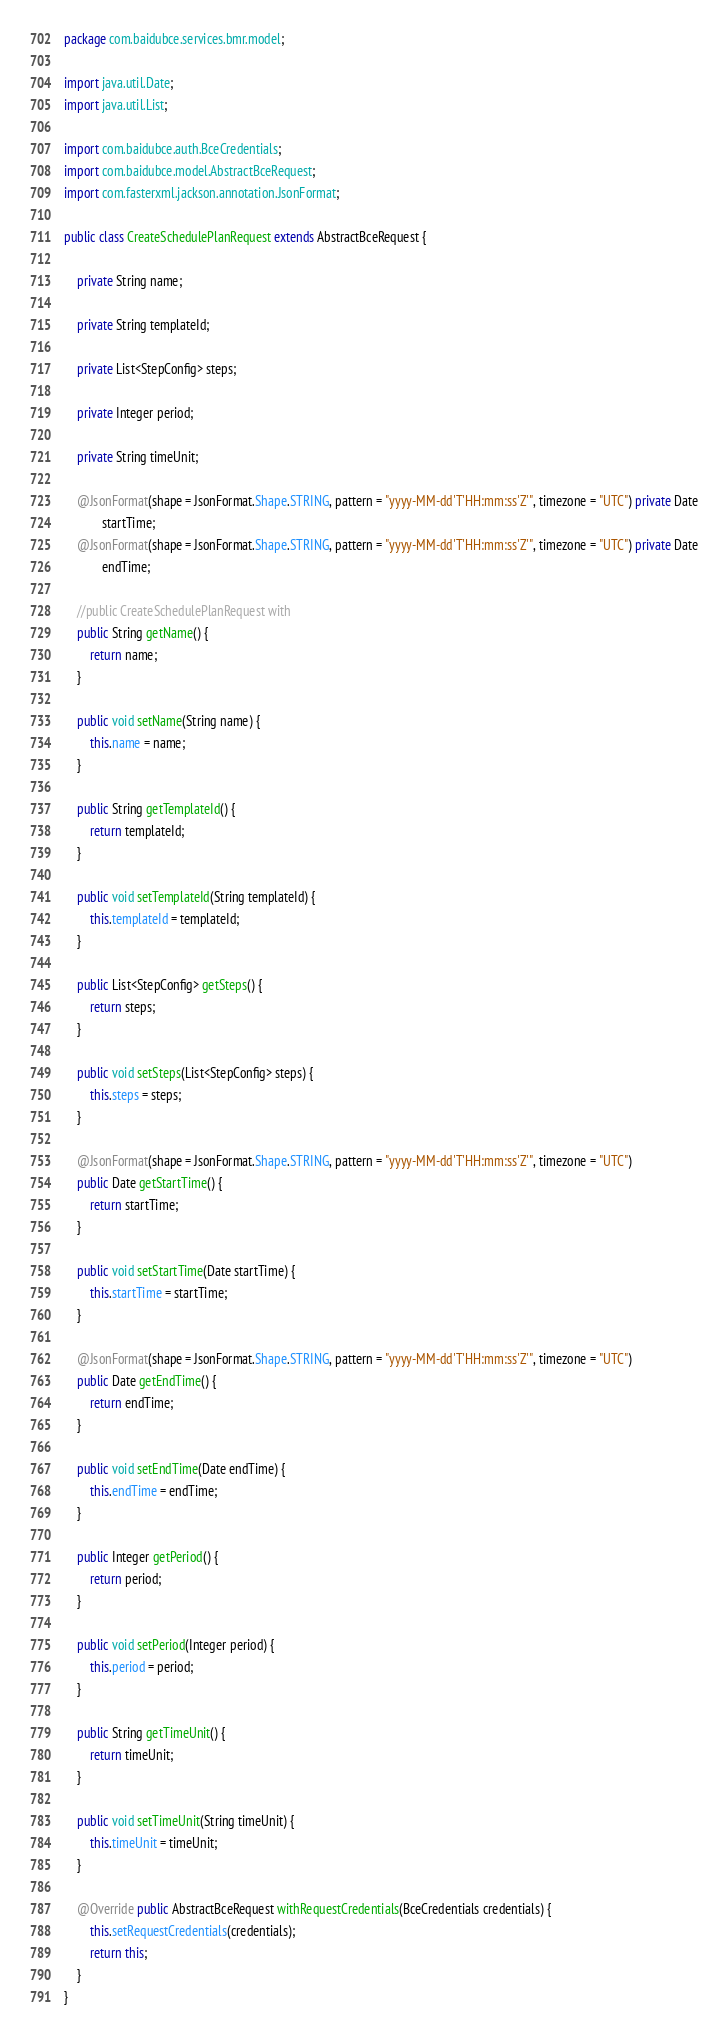<code> <loc_0><loc_0><loc_500><loc_500><_Java_>package com.baidubce.services.bmr.model;

import java.util.Date;
import java.util.List;

import com.baidubce.auth.BceCredentials;
import com.baidubce.model.AbstractBceRequest;
import com.fasterxml.jackson.annotation.JsonFormat;

public class CreateSchedulePlanRequest extends AbstractBceRequest {

    private String name;

    private String templateId;

    private List<StepConfig> steps;

    private Integer period;

    private String timeUnit;

    @JsonFormat(shape = JsonFormat.Shape.STRING, pattern = "yyyy-MM-dd'T'HH:mm:ss'Z'", timezone = "UTC") private Date
            startTime;
    @JsonFormat(shape = JsonFormat.Shape.STRING, pattern = "yyyy-MM-dd'T'HH:mm:ss'Z'", timezone = "UTC") private Date
            endTime;

    //public CreateSchedulePlanRequest with
    public String getName() {
        return name;
    }

    public void setName(String name) {
        this.name = name;
    }

    public String getTemplateId() {
        return templateId;
    }

    public void setTemplateId(String templateId) {
        this.templateId = templateId;
    }

    public List<StepConfig> getSteps() {
        return steps;
    }

    public void setSteps(List<StepConfig> steps) {
        this.steps = steps;
    }

    @JsonFormat(shape = JsonFormat.Shape.STRING, pattern = "yyyy-MM-dd'T'HH:mm:ss'Z'", timezone = "UTC")
    public Date getStartTime() {
        return startTime;
    }

    public void setStartTime(Date startTime) {
        this.startTime = startTime;
    }

    @JsonFormat(shape = JsonFormat.Shape.STRING, pattern = "yyyy-MM-dd'T'HH:mm:ss'Z'", timezone = "UTC")
    public Date getEndTime() {
        return endTime;
    }

    public void setEndTime(Date endTime) {
        this.endTime = endTime;
    }

    public Integer getPeriod() {
        return period;
    }

    public void setPeriod(Integer period) {
        this.period = period;
    }

    public String getTimeUnit() {
        return timeUnit;
    }

    public void setTimeUnit(String timeUnit) {
        this.timeUnit = timeUnit;
    }

    @Override public AbstractBceRequest withRequestCredentials(BceCredentials credentials) {
        this.setRequestCredentials(credentials);
        return this;
    }
}
</code> 